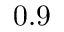Convert formula to latex. <formula><loc_0><loc_0><loc_500><loc_500>0 . 9</formula> 